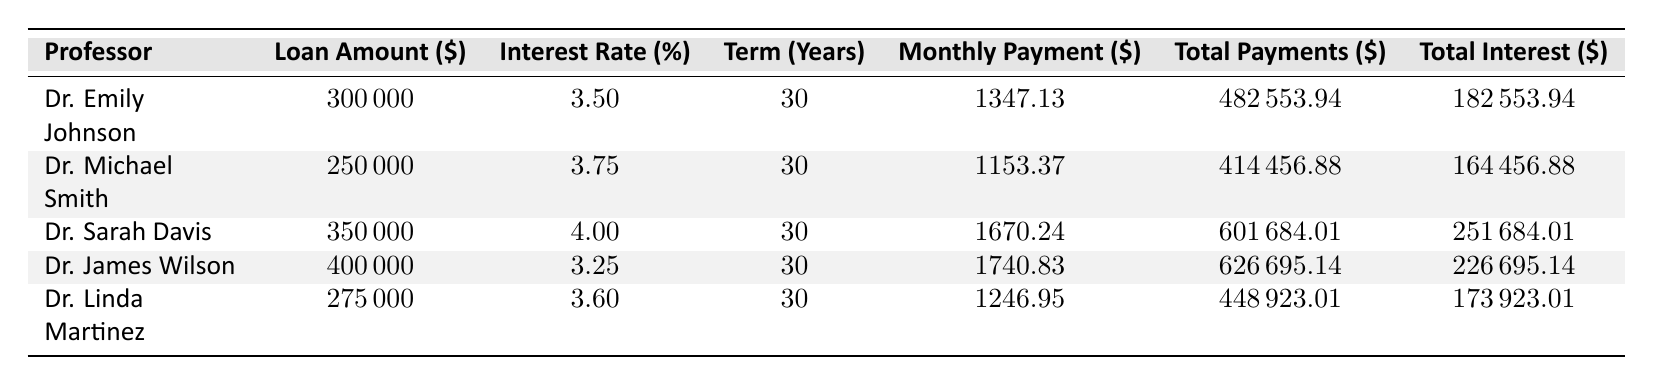What is the loan amount for Dr. Sarah Davis? In the table, I locate the row for Dr. Sarah Davis. According to the table, her loan amount is listed as 350,000 dollars.
Answer: 350,000 Is Dr. Emily Johnson's interest rate lower than Dr. Michael Smith's? I compare the interest rates in the table: Dr. Emily Johnson has an interest rate of 3.5%, while Dr. Michael Smith has an interest rate of 3.75%. Since 3.5% is less than 3.75%, the statement is true.
Answer: Yes What is the total interest paid by Dr. James Wilson? I examine the row for Dr. James Wilson in the table. The total interest paid is listed as 226,695.14 dollars.
Answer: 226,695.14 What is the average monthly payment for the professors listed? First, I sum the monthly payments: 1347.13 + 1153.37 + 1670.24 + 1740.83 + 1246.95 = 6138.52. There are 5 professors, so the average monthly payment is 6138.52 divided by 5, which equals 1227.70.
Answer: 1227.70 What is the total amount paid by all professors combined? I add up the total payments for each professor: 482,553.94 + 414,456.88 + 601,684.01 + 626,695.14 + 448,923.01 = 2,574,313.98.
Answer: 2,574,313.98 